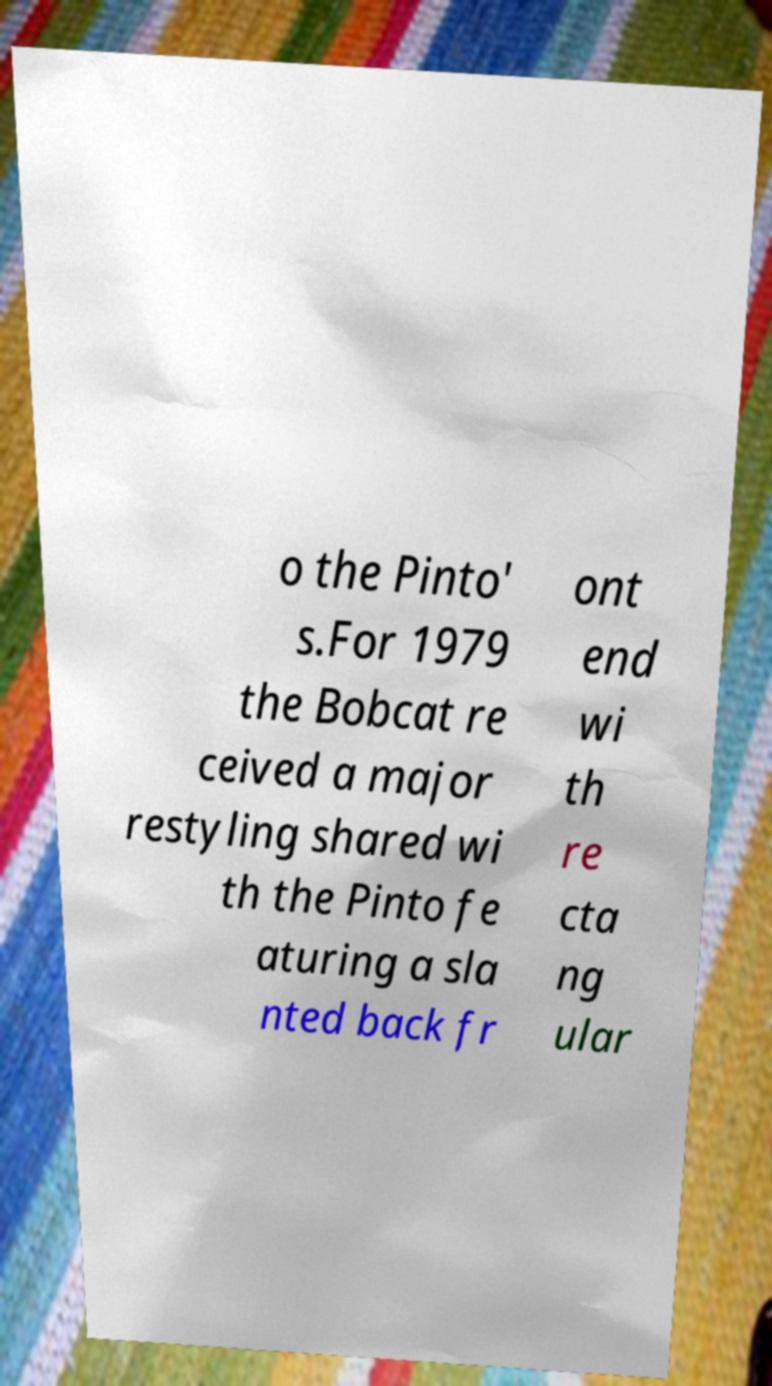Could you extract and type out the text from this image? o the Pinto' s.For 1979 the Bobcat re ceived a major restyling shared wi th the Pinto fe aturing a sla nted back fr ont end wi th re cta ng ular 